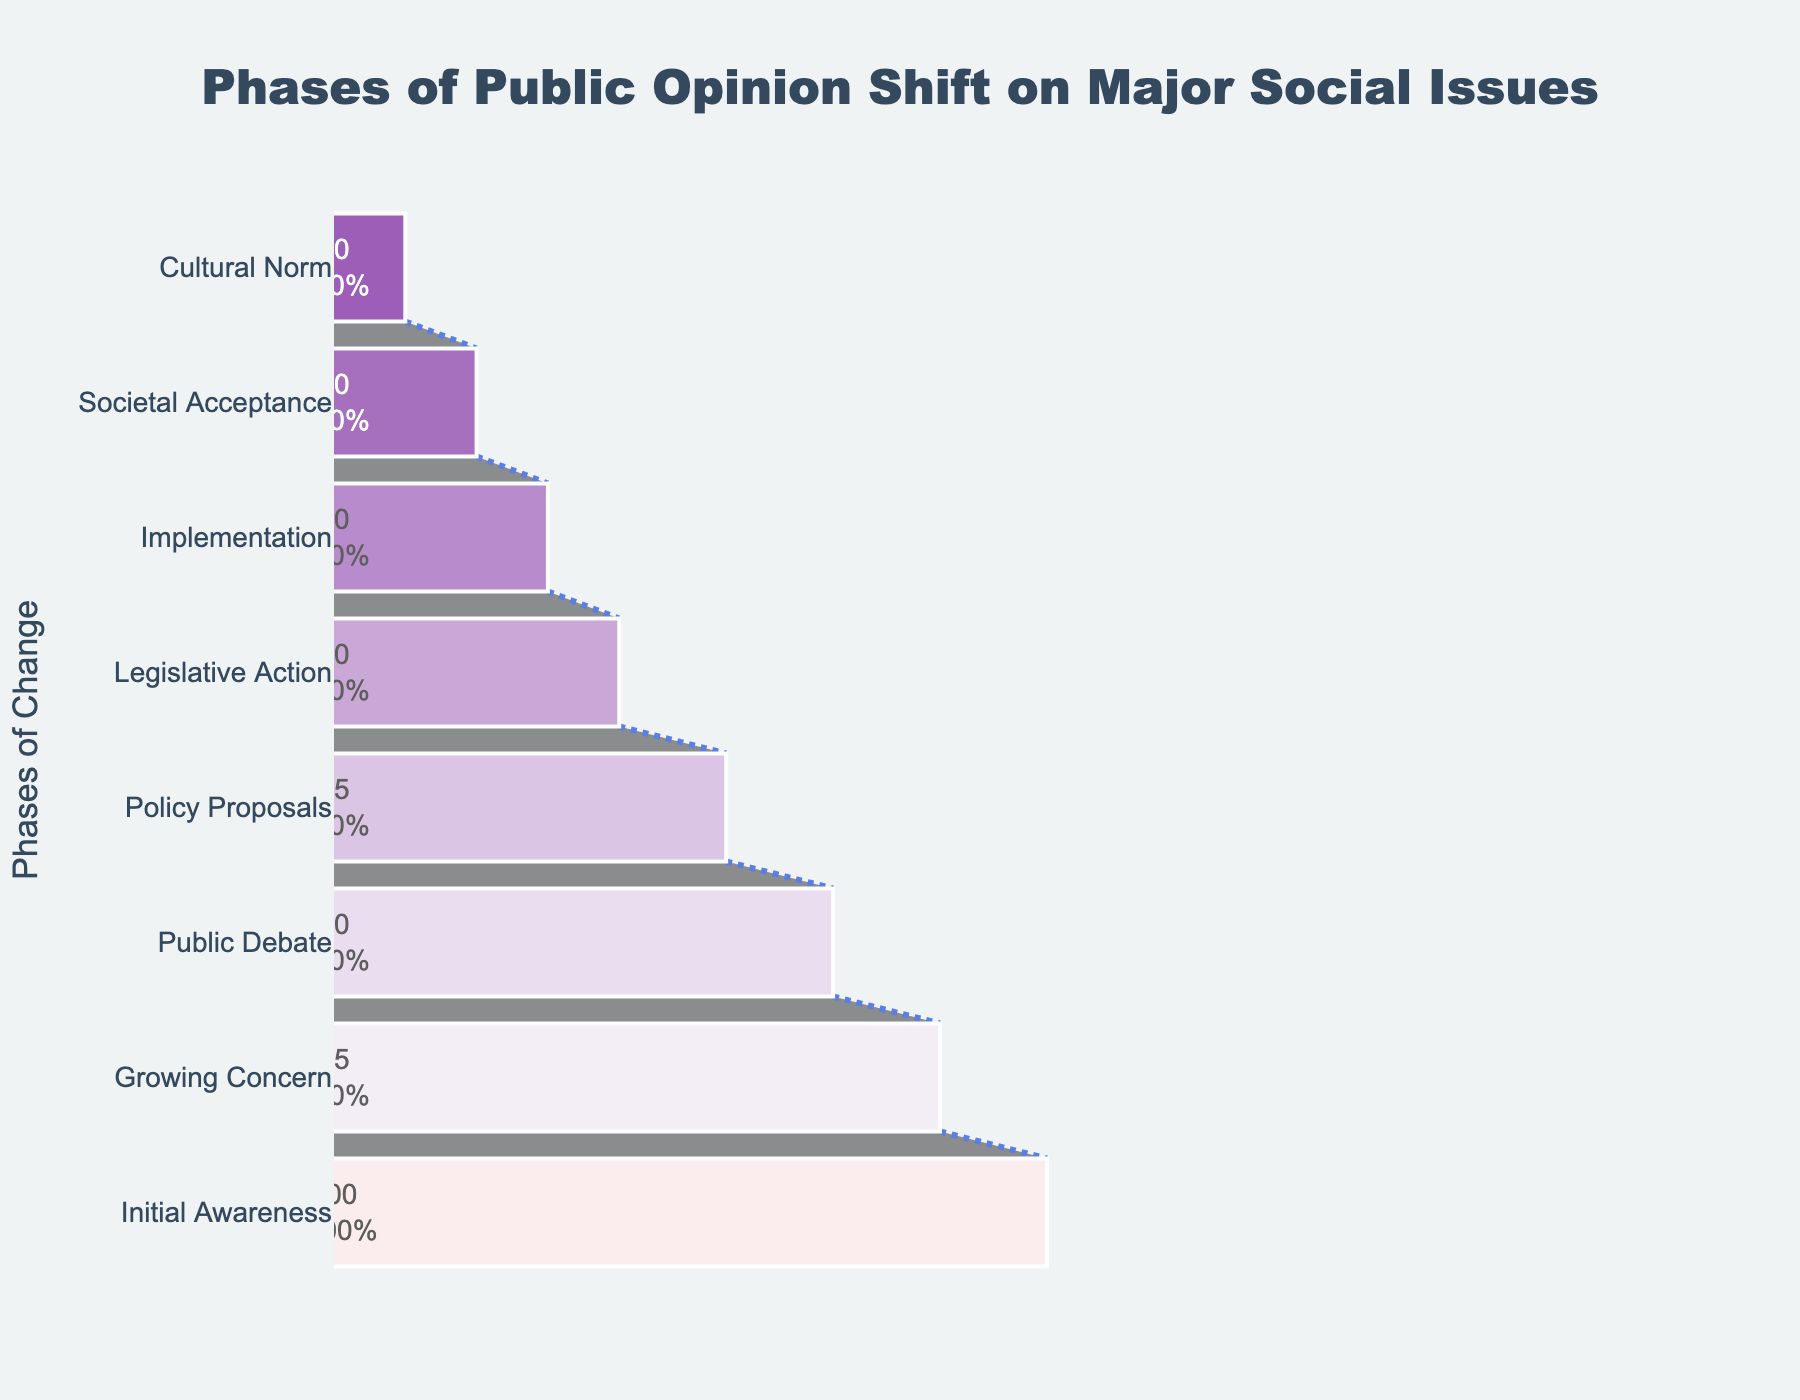What is the title of the Funnel Chart? The title is located at the top of the chart and provides a summary of what the chart represents.
Answer: Phases of Public Opinion Shift on Major Social Issues What percentage of people remain in the Public Debate phase? Locate the "Public Debate" phase on the vertical axis of the funnel chart and read the corresponding percentage value.
Answer: 70% Which phase shows a 100% engagement level in public opinion? Identify the phase at the top of the funnel chart, which represents the initial phase, and check its percentage.
Answer: Initial Awareness What is the total percentage decrease from Initial Awareness to Implementational phase? Find the percentage for the Initial Awareness (100%) and Implementation (30%) phases. Calculate the decrease by subtracting the percentage of the Implementation phase from the percentage of the Initial Awareness phase: 100% - 30%.
Answer: 70% Between which phases does the highest percentage drop occur? Examine the percentages between each consecutive phase and identify the largest difference.
Answer: Policy Proposals to Legislative Action What phases are involved in the transition from public debate to cultural norm, and by what total percentage do they reduce? Identify the phases between Public Debate and Cultural Norm and sum their reduction percentages: Public Debate (70%), Policy Proposals (55%), Legislative Action (40%), Implementation (30%), Societal Acceptance (20%), and Cultural Norm (10%). Calculate the percentage reduction stepwise from phase to phase.
Answer: Public Debate, Policy Proposals, Legislative Action, Implementation, Societal Acceptance, Cultural Norm; 60% Which phase has a lower percentage, Policy Proposals or Societal Acceptance? Locate both phases on the funnel chart and compare their respective percentages.
Answer: Societal Acceptance How many phases are shown in the Funnel Chart? Count the number of distinct phases listed on the vertical axis of the funnel chart.
Answer: Eight What can you infer about the trend of public opinion as issues move from Initial Awareness to Cultural Norm? Observing the gradual decrease in percentages from the top to the bottom of the funnel chart indicates that public support or engagement decreases significantly through each phase.
Answer: Decline in public engagement 